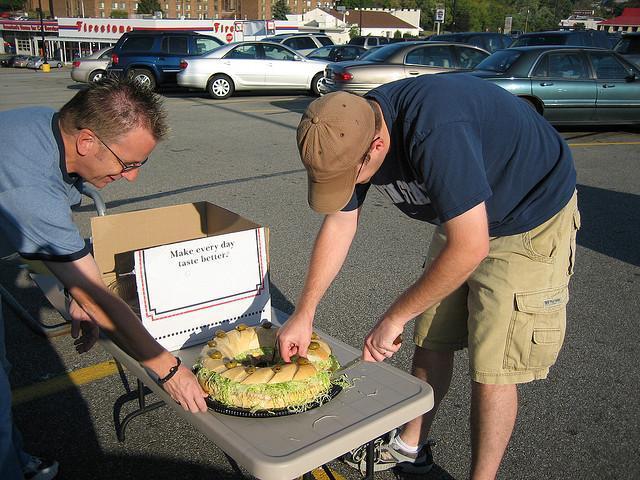How many cars are in the photo?
Give a very brief answer. 4. How many people can you see?
Give a very brief answer. 2. 